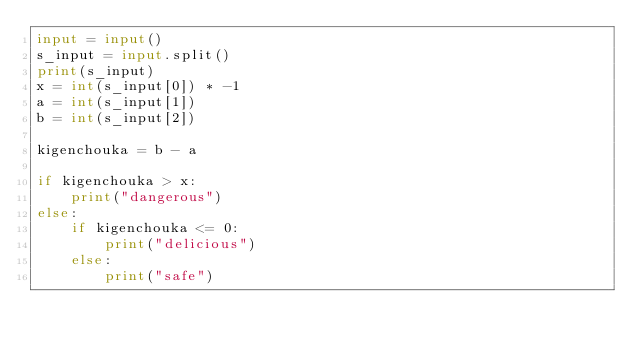<code> <loc_0><loc_0><loc_500><loc_500><_Python_>input = input()
s_input = input.split()
print(s_input)
x = int(s_input[0]) * -1
a = int(s_input[1])
b = int(s_input[2])

kigenchouka = b - a

if kigenchouka > x:
    print("dangerous")
else:
    if kigenchouka <= 0:
        print("delicious")
    else:
        print("safe")
</code> 